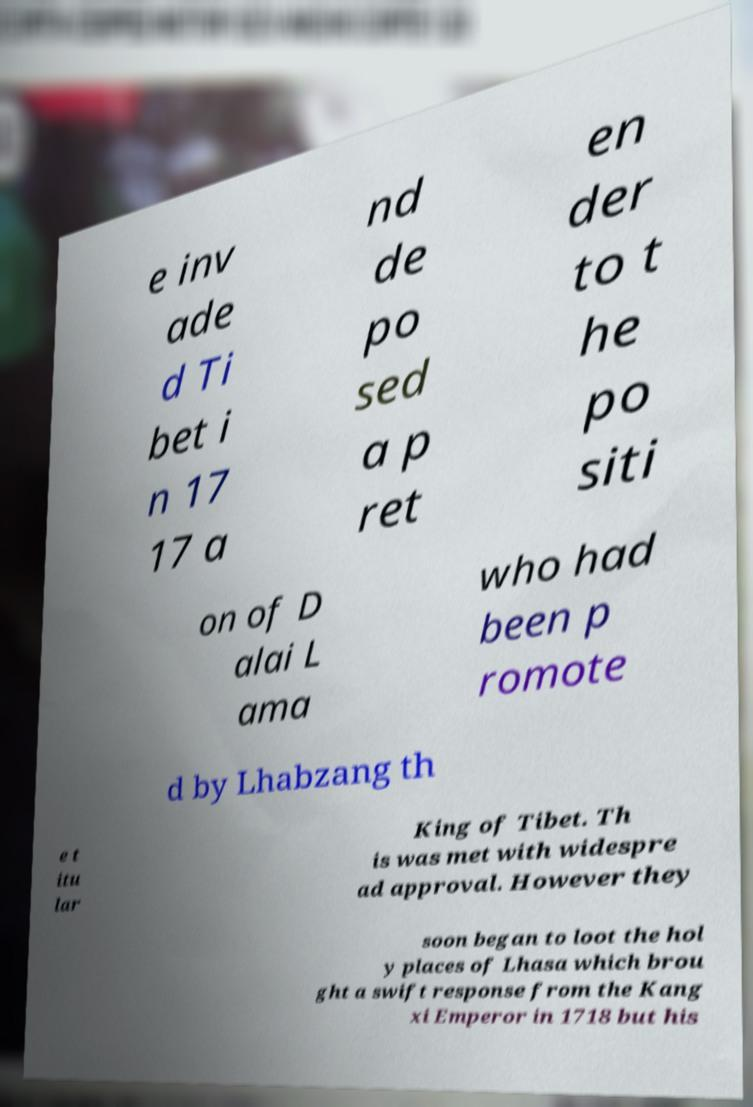What messages or text are displayed in this image? I need them in a readable, typed format. e inv ade d Ti bet i n 17 17 a nd de po sed a p ret en der to t he po siti on of D alai L ama who had been p romote d by Lhabzang th e t itu lar King of Tibet. Th is was met with widespre ad approval. However they soon began to loot the hol y places of Lhasa which brou ght a swift response from the Kang xi Emperor in 1718 but his 